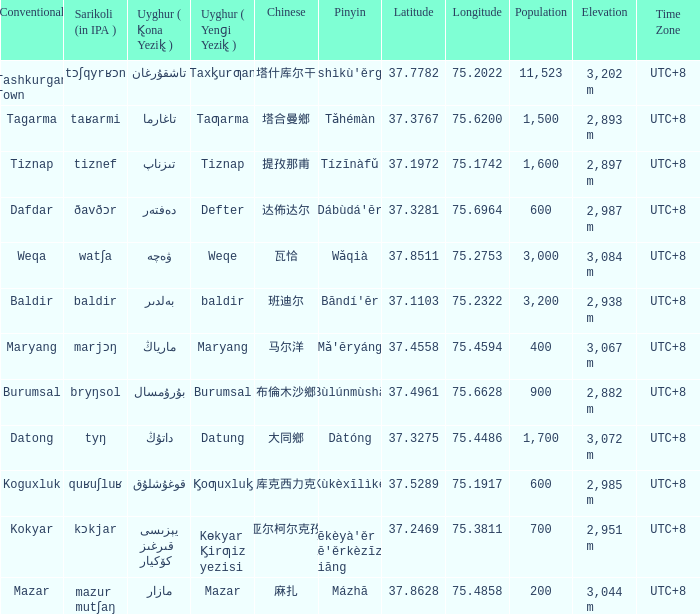Name the pinyin for mazar Mázhā. 